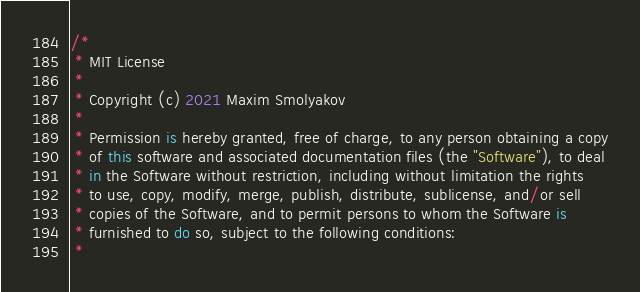Convert code to text. <code><loc_0><loc_0><loc_500><loc_500><_Kotlin_>/*
 * MIT License
 *
 * Copyright (c) 2021 Maxim Smolyakov
 *
 * Permission is hereby granted, free of charge, to any person obtaining a copy
 * of this software and associated documentation files (the "Software"), to deal
 * in the Software without restriction, including without limitation the rights
 * to use, copy, modify, merge, publish, distribute, sublicense, and/or sell
 * copies of the Software, and to permit persons to whom the Software is
 * furnished to do so, subject to the following conditions:
 *</code> 